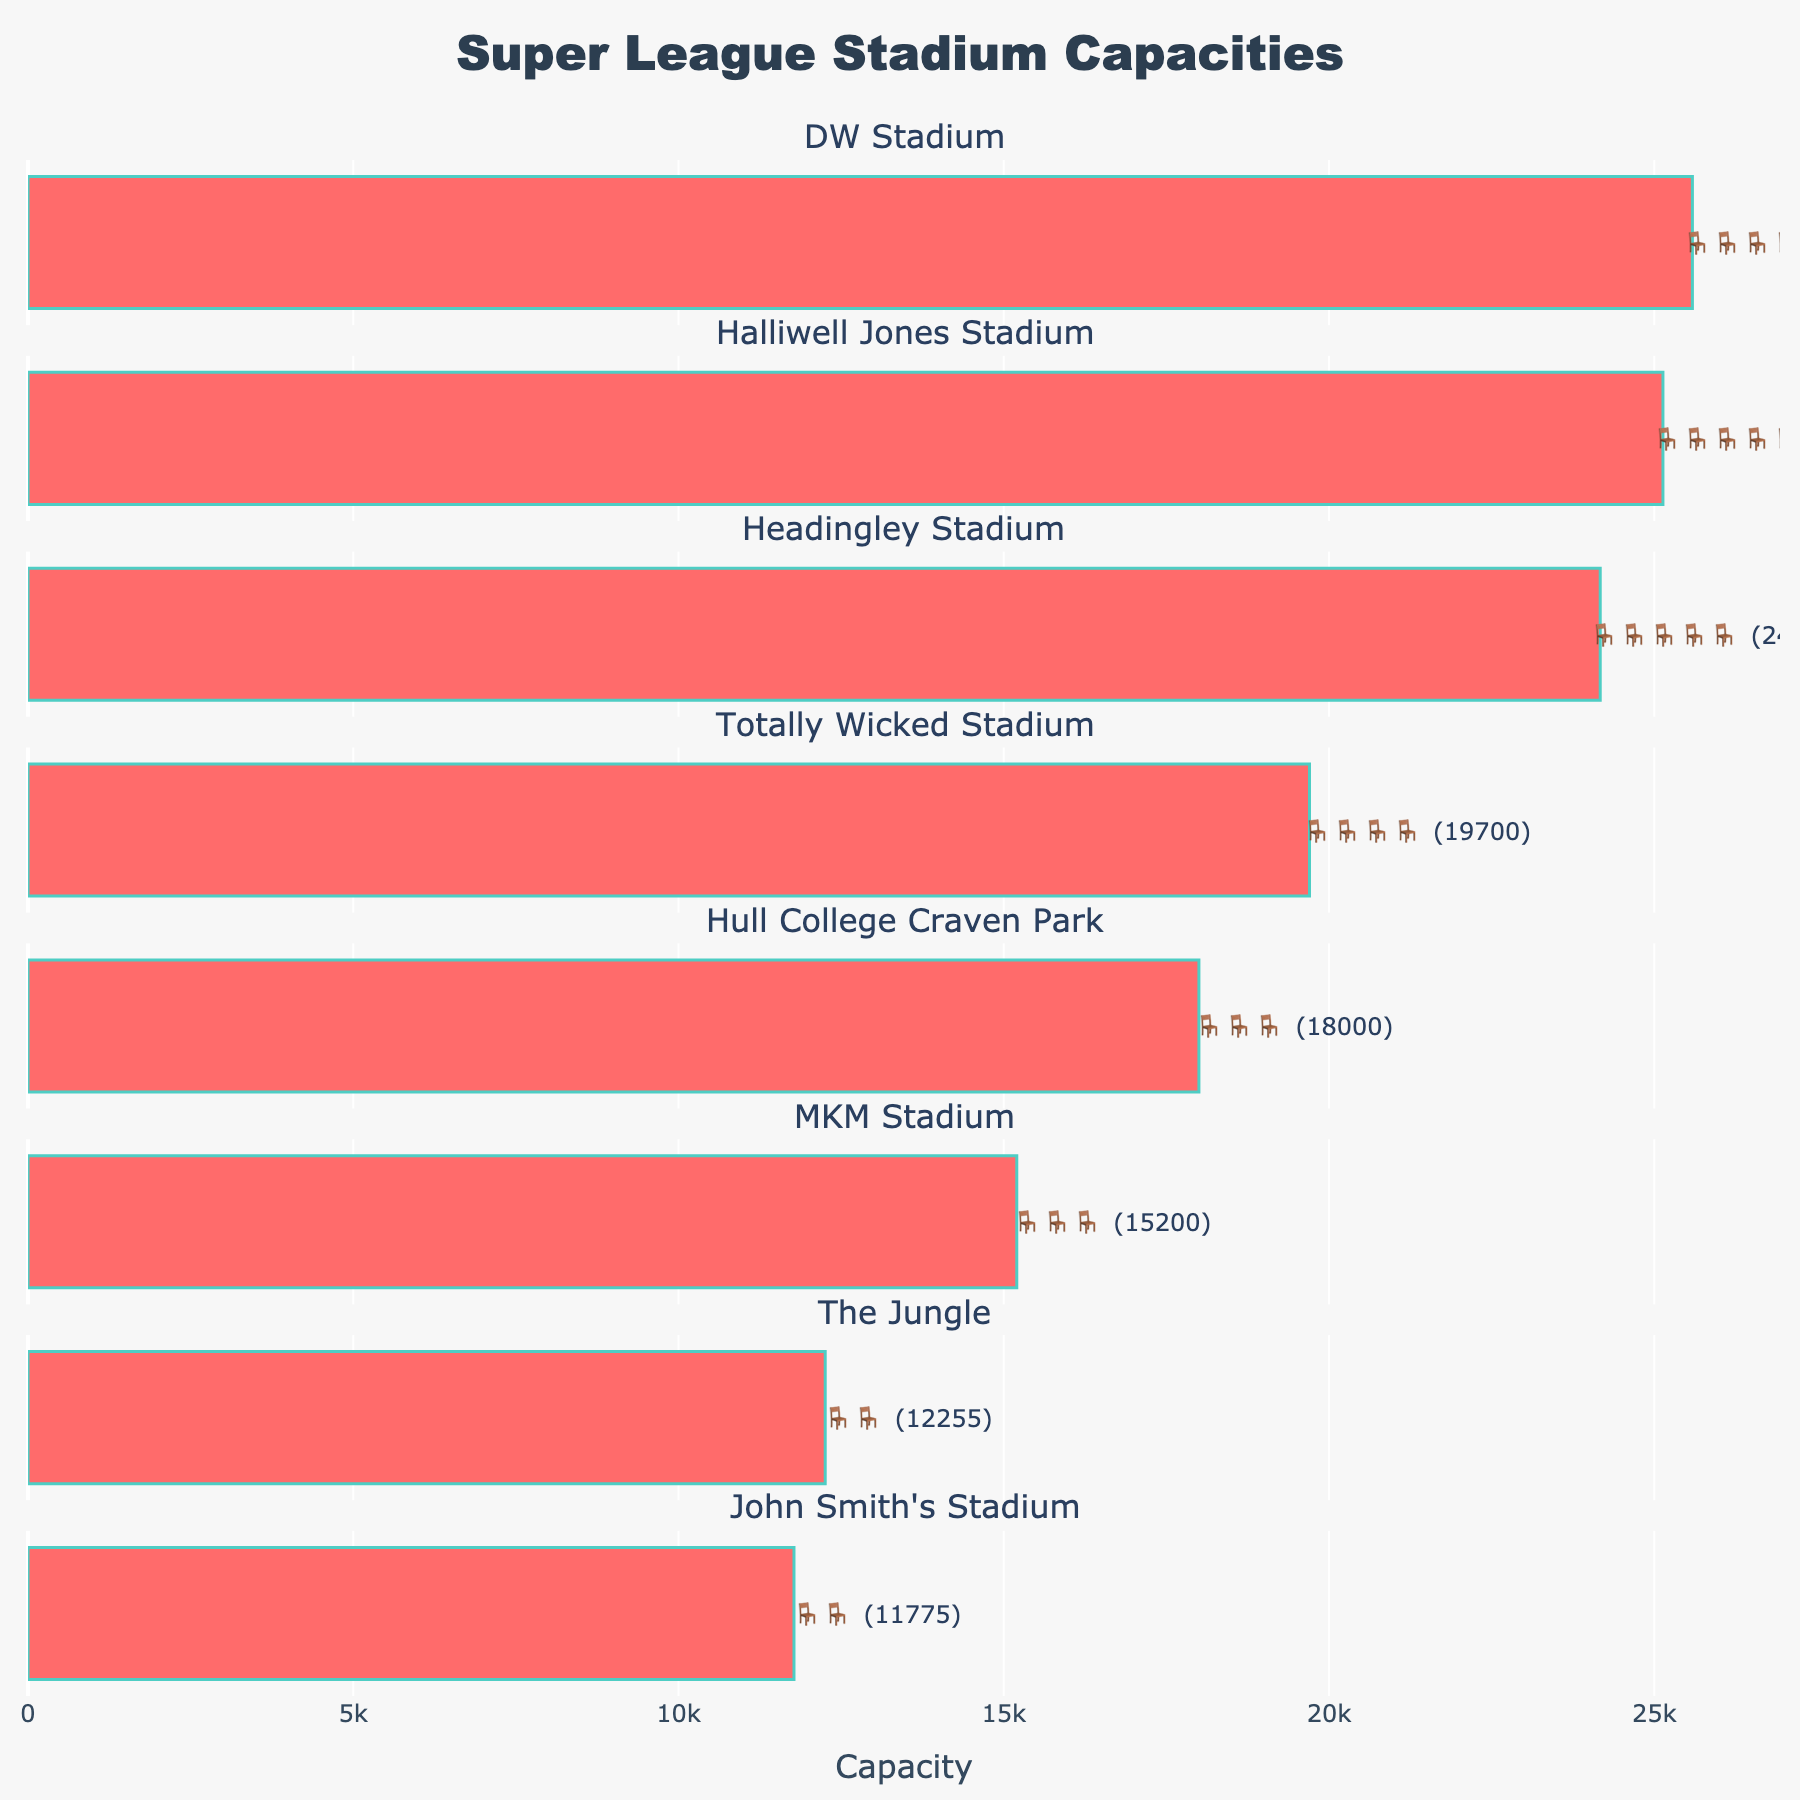What's the title of the plot? The title is usually displayed prominently at the top of the figure and typically summarizes the main information of the plot. In this case, it is stated in the code.
Answer: Super League Stadium Capacities Which stadium has the highest seating capacity? By checking the figure, the stadium with the longest bar indicates the highest seating capacity.
Answer: MKM Stadium How many stadiums have a seating capacity above 20,000? Count the bars where the capacity label is greater than 20,000.
Answer: 4 What is the total seating capacity of the three smallest stadiums? Identify the stadiums with the smallest capacities and sum these values.
Answer: 39230 Which stadiums have exactly four chair symbols in the plot? Look for the rows with exactly four chair symbols next to the capacity.
Answer: Headingley Stadium, John Smith's Stadium What is the difference in seating capacity between the Hull college Craven Park and The Jungle? Subtract the capacity of The Jungle from Hull College Craven Park.
Answer: 480 Which stadium has slightly less capacity than the DW Stadium? Find the stadium with a capacity just less than 25133.
Answer: John Smith's Stadium If you were to average the seating capacities of all the stadiums, what would that come to? Sum the capacities of all the stadiums and divide by the number of stadiums. (25133 + 15200 + 19700 + 18000 + 12255 + 25586 + 11775 + 24169) / 8
Answer: 18902 Is the seating capacity of the Totally Wicked Stadium closer to the capacity of the DW Stadium or Halliwell Jones Stadium? Calculate the absolute difference between the capacities of Totally Wicked Stadium and DW Stadium, and Totally Wicked Stadium and Halliwell Jones Stadium. Then compare these two differences.
Answer: DW Stadium 